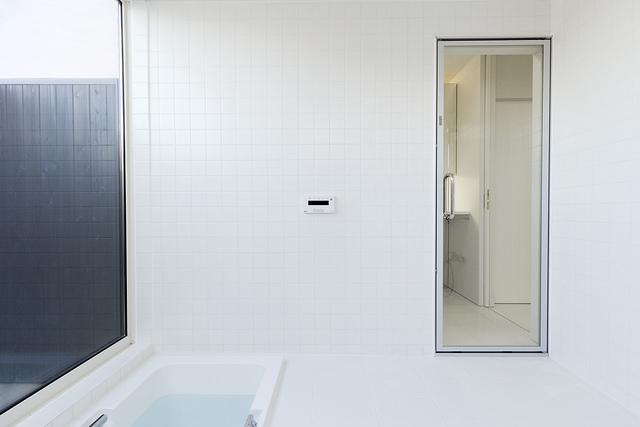What color is the wall?
Short answer required. White. Do you see a grandfather clock?
Be succinct. No. Is the floor in the bathroom cool and hard or soft and plush?
Give a very brief answer. Cool and hard. What is covering the wall?
Concise answer only. Tile. What is inside the shower stall?
Concise answer only. Nothing. 